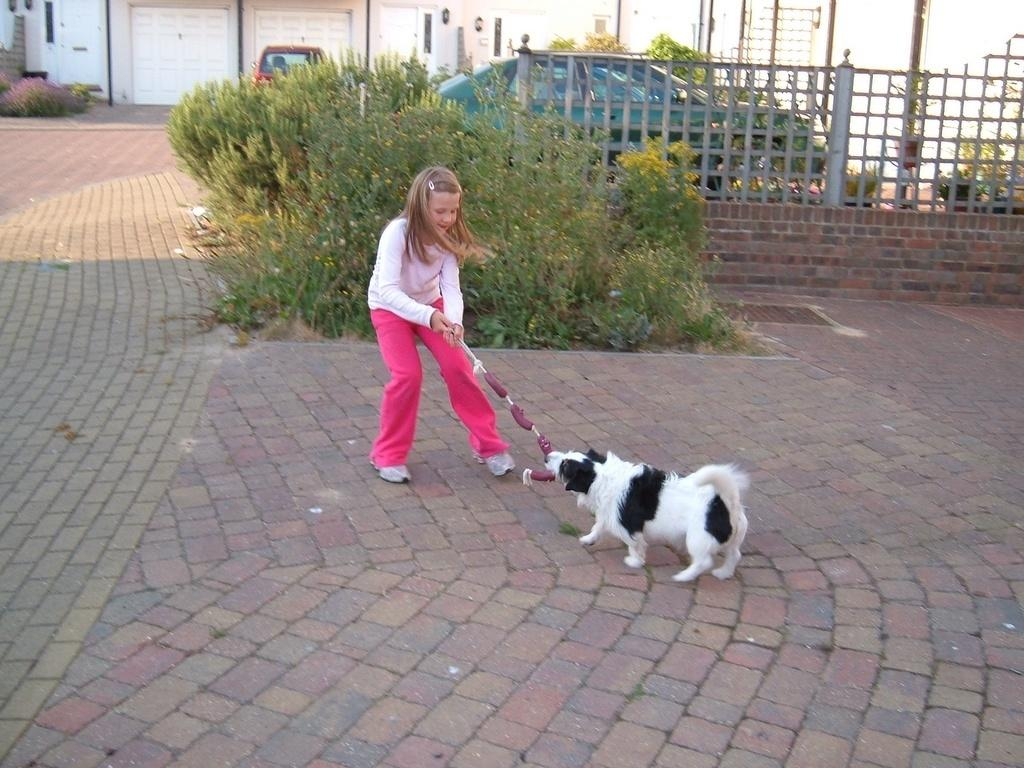Who is present in the image? There is a girl in the image. What is the girl doing in the image? The girl is playing with a dog. What other objects or elements can be seen in the image? There is a plant, a vehicle, fencing, and a house in the image. What type of judge is depicted in the image? There is no judge present in the image. Is the girl playing basketball with the dog in the image? There is no basketball present in the image; the girl is playing with a dog. Is the girl driving the vehicle in the image? There is no indication that the girl is driving the vehicle in the image. 